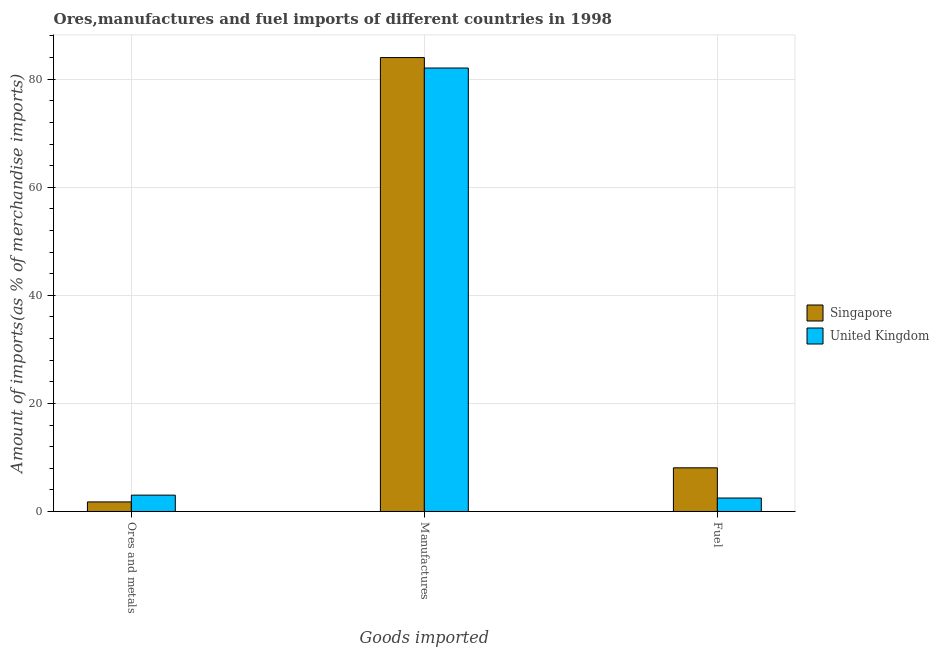How many different coloured bars are there?
Provide a short and direct response. 2. How many groups of bars are there?
Offer a terse response. 3. Are the number of bars per tick equal to the number of legend labels?
Your response must be concise. Yes. How many bars are there on the 2nd tick from the left?
Provide a short and direct response. 2. What is the label of the 1st group of bars from the left?
Ensure brevity in your answer.  Ores and metals. What is the percentage of manufactures imports in United Kingdom?
Your answer should be very brief. 82.07. Across all countries, what is the maximum percentage of ores and metals imports?
Provide a short and direct response. 3.03. Across all countries, what is the minimum percentage of ores and metals imports?
Ensure brevity in your answer.  1.77. In which country was the percentage of ores and metals imports maximum?
Offer a terse response. United Kingdom. What is the total percentage of manufactures imports in the graph?
Your answer should be very brief. 166.07. What is the difference between the percentage of manufactures imports in United Kingdom and that in Singapore?
Offer a terse response. -1.93. What is the difference between the percentage of manufactures imports in United Kingdom and the percentage of ores and metals imports in Singapore?
Provide a succinct answer. 80.3. What is the average percentage of ores and metals imports per country?
Your answer should be compact. 2.4. What is the difference between the percentage of manufactures imports and percentage of ores and metals imports in Singapore?
Keep it short and to the point. 82.23. In how many countries, is the percentage of manufactures imports greater than 28 %?
Offer a terse response. 2. What is the ratio of the percentage of fuel imports in United Kingdom to that in Singapore?
Keep it short and to the point. 0.31. Is the percentage of fuel imports in United Kingdom less than that in Singapore?
Provide a succinct answer. Yes. Is the difference between the percentage of fuel imports in United Kingdom and Singapore greater than the difference between the percentage of ores and metals imports in United Kingdom and Singapore?
Give a very brief answer. No. What is the difference between the highest and the second highest percentage of manufactures imports?
Give a very brief answer. 1.93. What is the difference between the highest and the lowest percentage of manufactures imports?
Your answer should be compact. 1.93. Is the sum of the percentage of manufactures imports in Singapore and United Kingdom greater than the maximum percentage of ores and metals imports across all countries?
Offer a terse response. Yes. What does the 1st bar from the right in Fuel represents?
Provide a short and direct response. United Kingdom. Is it the case that in every country, the sum of the percentage of ores and metals imports and percentage of manufactures imports is greater than the percentage of fuel imports?
Your answer should be very brief. Yes. How many bars are there?
Your answer should be very brief. 6. Are all the bars in the graph horizontal?
Keep it short and to the point. No. What is the difference between two consecutive major ticks on the Y-axis?
Keep it short and to the point. 20. Are the values on the major ticks of Y-axis written in scientific E-notation?
Your answer should be very brief. No. Does the graph contain grids?
Offer a terse response. Yes. How many legend labels are there?
Your answer should be very brief. 2. How are the legend labels stacked?
Provide a succinct answer. Vertical. What is the title of the graph?
Ensure brevity in your answer.  Ores,manufactures and fuel imports of different countries in 1998. Does "Cambodia" appear as one of the legend labels in the graph?
Make the answer very short. No. What is the label or title of the X-axis?
Offer a very short reply. Goods imported. What is the label or title of the Y-axis?
Give a very brief answer. Amount of imports(as % of merchandise imports). What is the Amount of imports(as % of merchandise imports) of Singapore in Ores and metals?
Your answer should be compact. 1.77. What is the Amount of imports(as % of merchandise imports) in United Kingdom in Ores and metals?
Make the answer very short. 3.03. What is the Amount of imports(as % of merchandise imports) in Singapore in Manufactures?
Your answer should be compact. 84. What is the Amount of imports(as % of merchandise imports) in United Kingdom in Manufactures?
Ensure brevity in your answer.  82.07. What is the Amount of imports(as % of merchandise imports) in Singapore in Fuel?
Make the answer very short. 8.08. What is the Amount of imports(as % of merchandise imports) of United Kingdom in Fuel?
Your answer should be very brief. 2.49. Across all Goods imported, what is the maximum Amount of imports(as % of merchandise imports) of Singapore?
Make the answer very short. 84. Across all Goods imported, what is the maximum Amount of imports(as % of merchandise imports) of United Kingdom?
Your answer should be compact. 82.07. Across all Goods imported, what is the minimum Amount of imports(as % of merchandise imports) in Singapore?
Your answer should be very brief. 1.77. Across all Goods imported, what is the minimum Amount of imports(as % of merchandise imports) of United Kingdom?
Keep it short and to the point. 2.49. What is the total Amount of imports(as % of merchandise imports) in Singapore in the graph?
Make the answer very short. 93.85. What is the total Amount of imports(as % of merchandise imports) in United Kingdom in the graph?
Give a very brief answer. 87.59. What is the difference between the Amount of imports(as % of merchandise imports) of Singapore in Ores and metals and that in Manufactures?
Give a very brief answer. -82.23. What is the difference between the Amount of imports(as % of merchandise imports) in United Kingdom in Ores and metals and that in Manufactures?
Offer a terse response. -79.04. What is the difference between the Amount of imports(as % of merchandise imports) of Singapore in Ores and metals and that in Fuel?
Keep it short and to the point. -6.31. What is the difference between the Amount of imports(as % of merchandise imports) of United Kingdom in Ores and metals and that in Fuel?
Your response must be concise. 0.53. What is the difference between the Amount of imports(as % of merchandise imports) of Singapore in Manufactures and that in Fuel?
Your response must be concise. 75.92. What is the difference between the Amount of imports(as % of merchandise imports) in United Kingdom in Manufactures and that in Fuel?
Provide a succinct answer. 79.57. What is the difference between the Amount of imports(as % of merchandise imports) in Singapore in Ores and metals and the Amount of imports(as % of merchandise imports) in United Kingdom in Manufactures?
Provide a succinct answer. -80.3. What is the difference between the Amount of imports(as % of merchandise imports) in Singapore in Ores and metals and the Amount of imports(as % of merchandise imports) in United Kingdom in Fuel?
Your answer should be very brief. -0.72. What is the difference between the Amount of imports(as % of merchandise imports) in Singapore in Manufactures and the Amount of imports(as % of merchandise imports) in United Kingdom in Fuel?
Give a very brief answer. 81.51. What is the average Amount of imports(as % of merchandise imports) of Singapore per Goods imported?
Provide a short and direct response. 31.28. What is the average Amount of imports(as % of merchandise imports) of United Kingdom per Goods imported?
Offer a terse response. 29.2. What is the difference between the Amount of imports(as % of merchandise imports) in Singapore and Amount of imports(as % of merchandise imports) in United Kingdom in Ores and metals?
Keep it short and to the point. -1.25. What is the difference between the Amount of imports(as % of merchandise imports) in Singapore and Amount of imports(as % of merchandise imports) in United Kingdom in Manufactures?
Your answer should be compact. 1.93. What is the difference between the Amount of imports(as % of merchandise imports) of Singapore and Amount of imports(as % of merchandise imports) of United Kingdom in Fuel?
Provide a succinct answer. 5.59. What is the ratio of the Amount of imports(as % of merchandise imports) in Singapore in Ores and metals to that in Manufactures?
Provide a short and direct response. 0.02. What is the ratio of the Amount of imports(as % of merchandise imports) in United Kingdom in Ores and metals to that in Manufactures?
Provide a succinct answer. 0.04. What is the ratio of the Amount of imports(as % of merchandise imports) of Singapore in Ores and metals to that in Fuel?
Offer a terse response. 0.22. What is the ratio of the Amount of imports(as % of merchandise imports) in United Kingdom in Ores and metals to that in Fuel?
Offer a very short reply. 1.21. What is the ratio of the Amount of imports(as % of merchandise imports) of Singapore in Manufactures to that in Fuel?
Give a very brief answer. 10.4. What is the ratio of the Amount of imports(as % of merchandise imports) of United Kingdom in Manufactures to that in Fuel?
Keep it short and to the point. 32.93. What is the difference between the highest and the second highest Amount of imports(as % of merchandise imports) of Singapore?
Make the answer very short. 75.92. What is the difference between the highest and the second highest Amount of imports(as % of merchandise imports) in United Kingdom?
Your answer should be very brief. 79.04. What is the difference between the highest and the lowest Amount of imports(as % of merchandise imports) of Singapore?
Ensure brevity in your answer.  82.23. What is the difference between the highest and the lowest Amount of imports(as % of merchandise imports) of United Kingdom?
Keep it short and to the point. 79.57. 